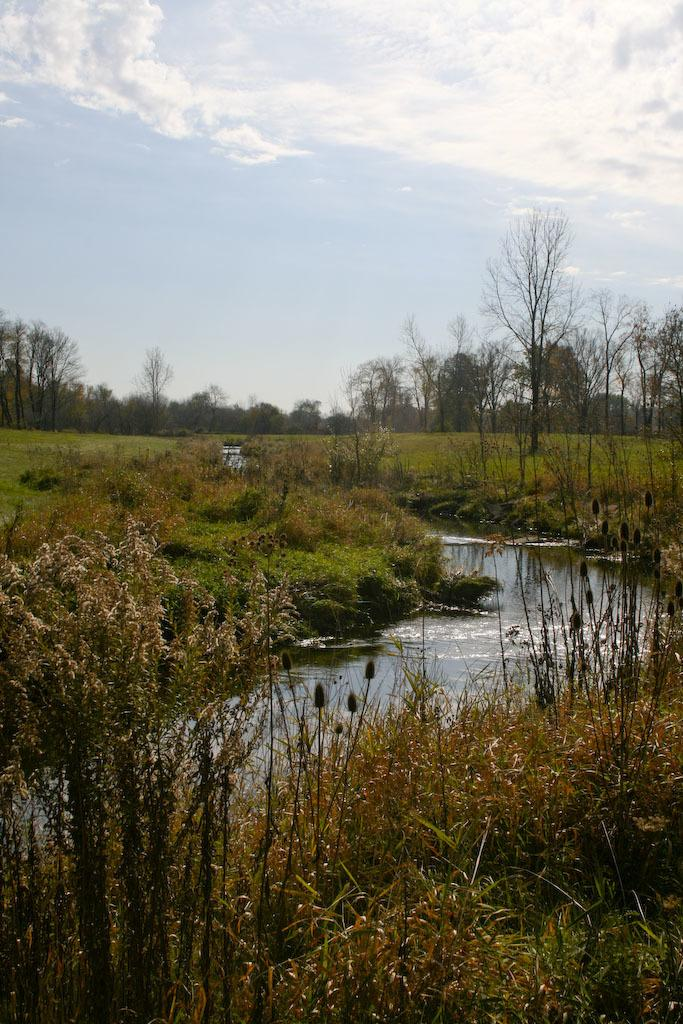What type of vegetation can be seen in the image? There is grass, plants, and trees visible in the image. What natural element is present in the image besides vegetation? There is water visible in the image. What is visible in the background of the image? The sky is visible in the image, and clouds are present in the sky. What condition is the rail in the image? There is no rail present in the image. How many family members can be seen in the image? There are no family members depicted in the image. 